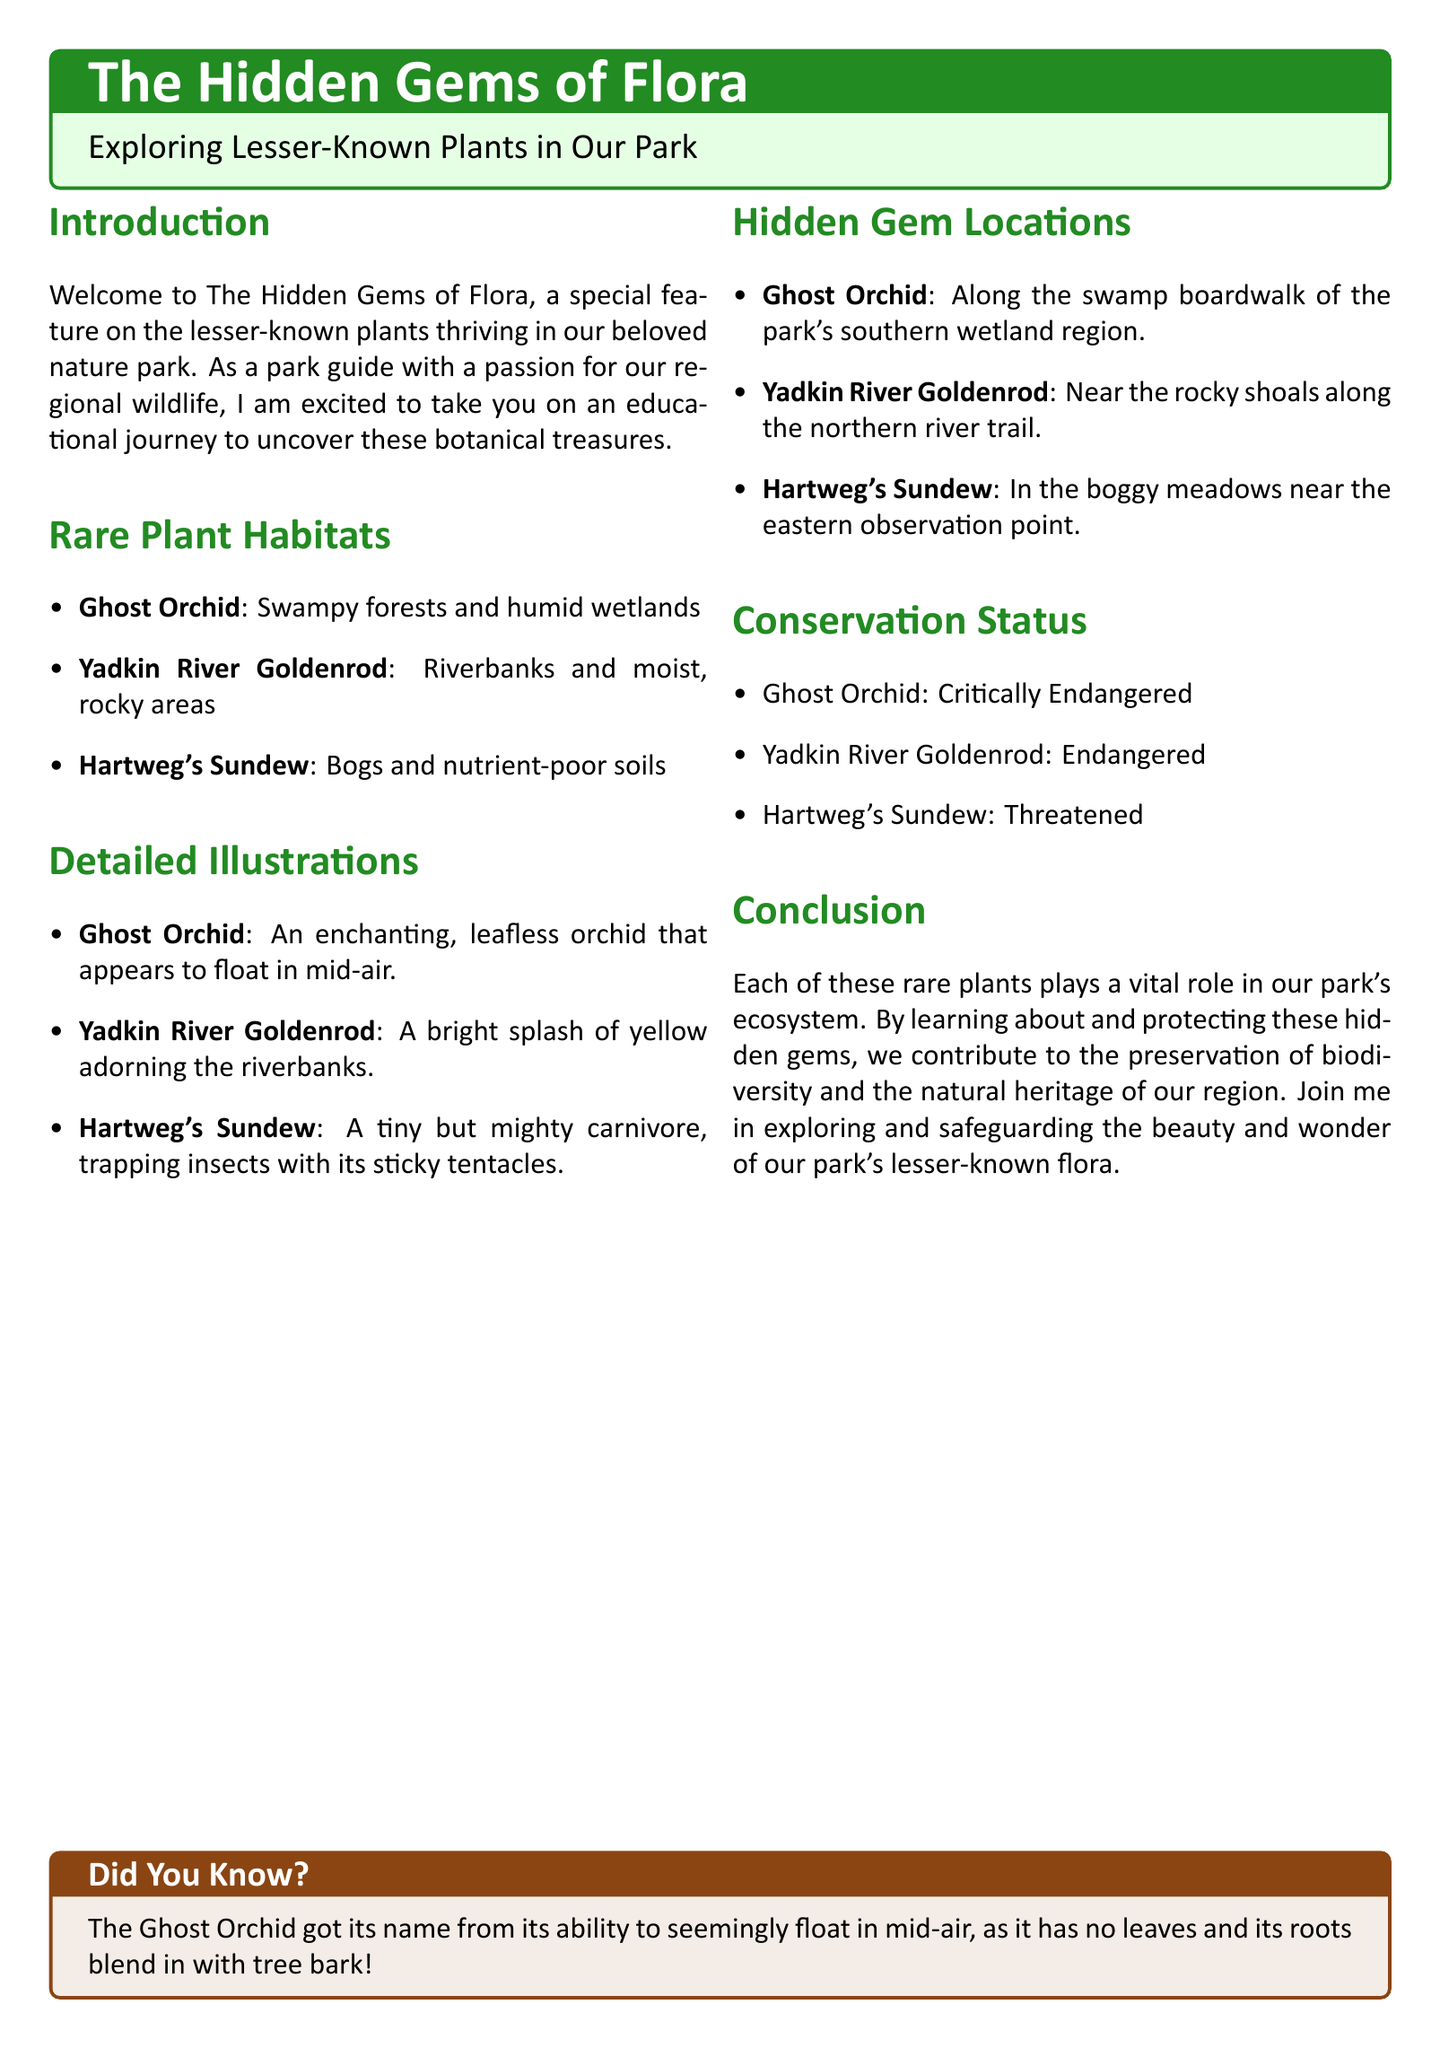What is the title of the article? The title is presented in a prominent box at the top of the document.
Answer: The Hidden Gems of Flora How many rare plants are mentioned in the document? The document lists three specific rare plants in the habitats section.
Answer: Three Where can you find the Ghost Orchid in the park? The location is detailed in the Hidden Gem Locations section.
Answer: Along the swamp boardwalk What does the Yadkin River Goldenrod look like? The description of the plant is found in the Detailed Illustrations section.
Answer: A bright splash of yellow What is the conservation status of the Hartweg's Sundew? The conservation status is stated in the Conservation Status section.
Answer: Threatened Why is the Ghost Orchid referred to as such? The reason is explained in the Did You Know box at the bottom.
Answer: It appears to float in mid-air What type of habitat is home to the Yadkin River Goldenrod? The specific habitat is outlined in the Rare Plant Habitats section.
Answer: Riverbanks and moist, rocky areas What is the color of the text used for section titles? The document indicates the color used for headings in the title format.
Answer: Forest green 